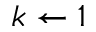<formula> <loc_0><loc_0><loc_500><loc_500>k \leftarrow 1</formula> 